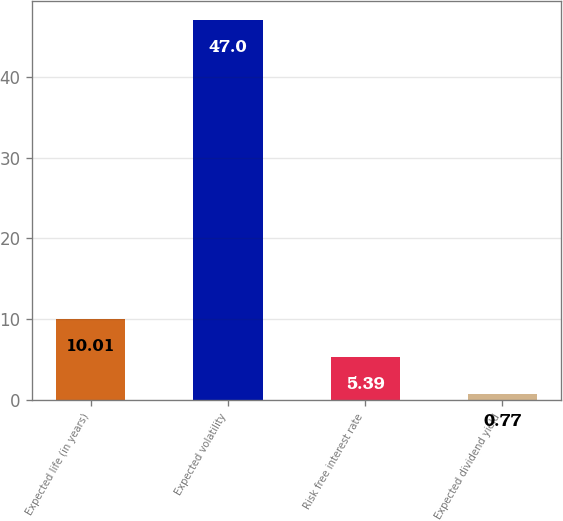Convert chart to OTSL. <chart><loc_0><loc_0><loc_500><loc_500><bar_chart><fcel>Expected life (in years)<fcel>Expected volatility<fcel>Risk free interest rate<fcel>Expected dividend yield<nl><fcel>10.01<fcel>47<fcel>5.39<fcel>0.77<nl></chart> 